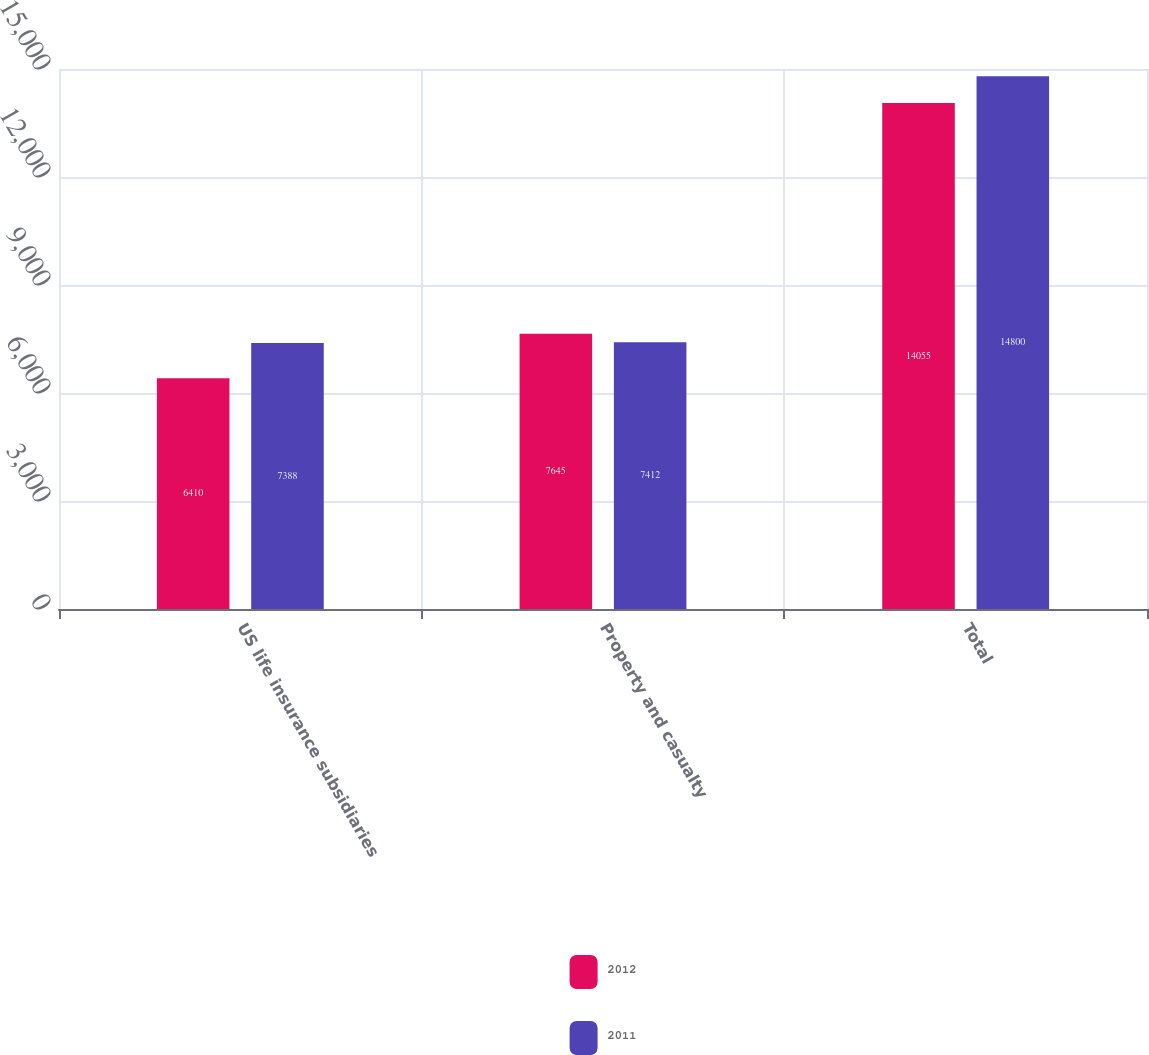Convert chart to OTSL. <chart><loc_0><loc_0><loc_500><loc_500><stacked_bar_chart><ecel><fcel>US life insurance subsidiaries<fcel>Property and casualty<fcel>Total<nl><fcel>2012<fcel>6410<fcel>7645<fcel>14055<nl><fcel>2011<fcel>7388<fcel>7412<fcel>14800<nl></chart> 